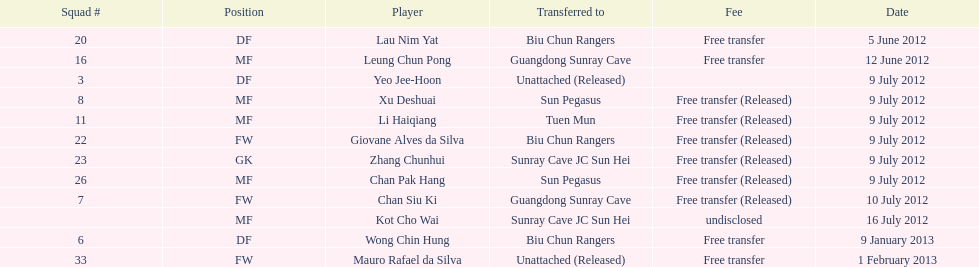In which position did li haiqiang and xu deshuai both play? MF. 